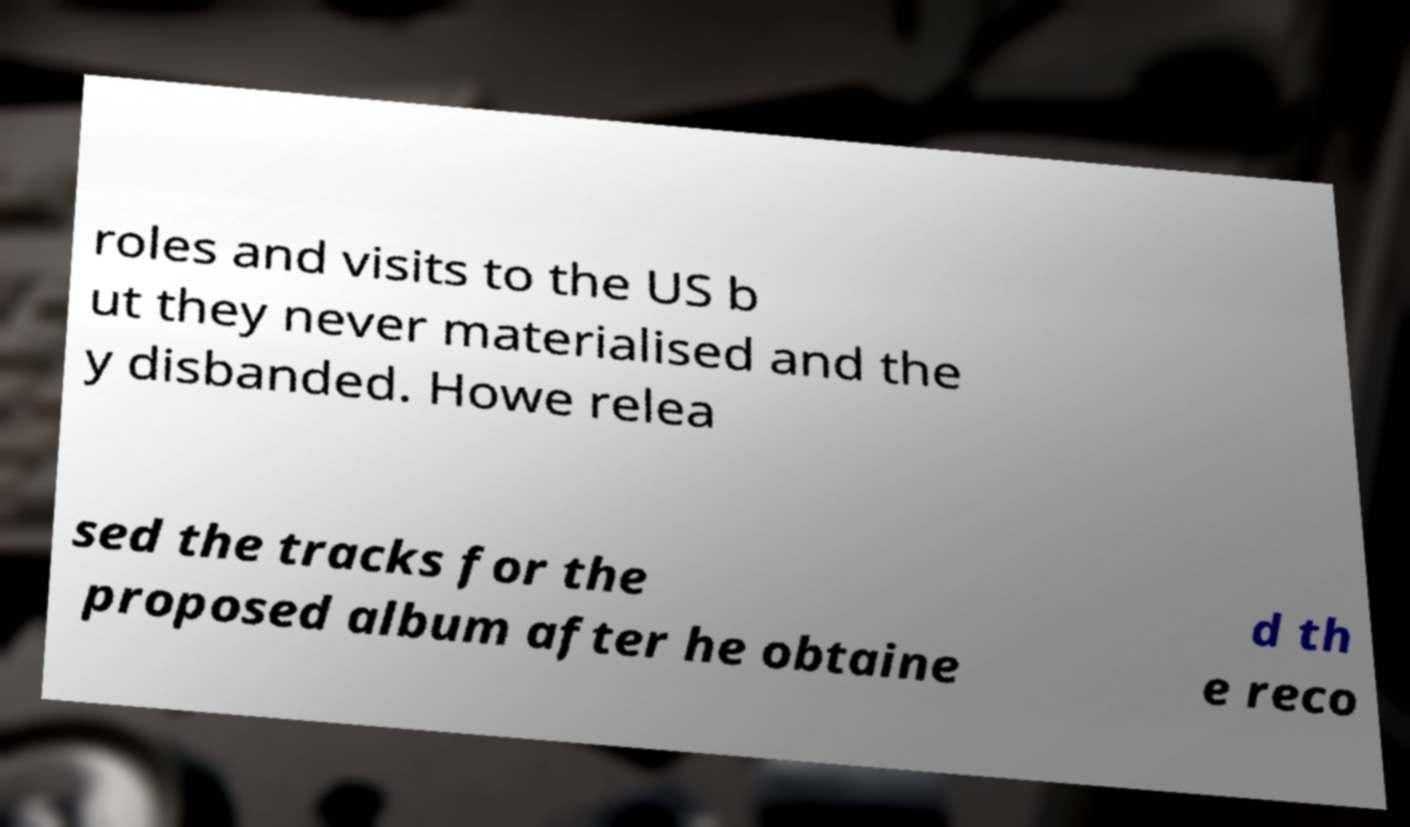There's text embedded in this image that I need extracted. Can you transcribe it verbatim? roles and visits to the US b ut they never materialised and the y disbanded. Howe relea sed the tracks for the proposed album after he obtaine d th e reco 